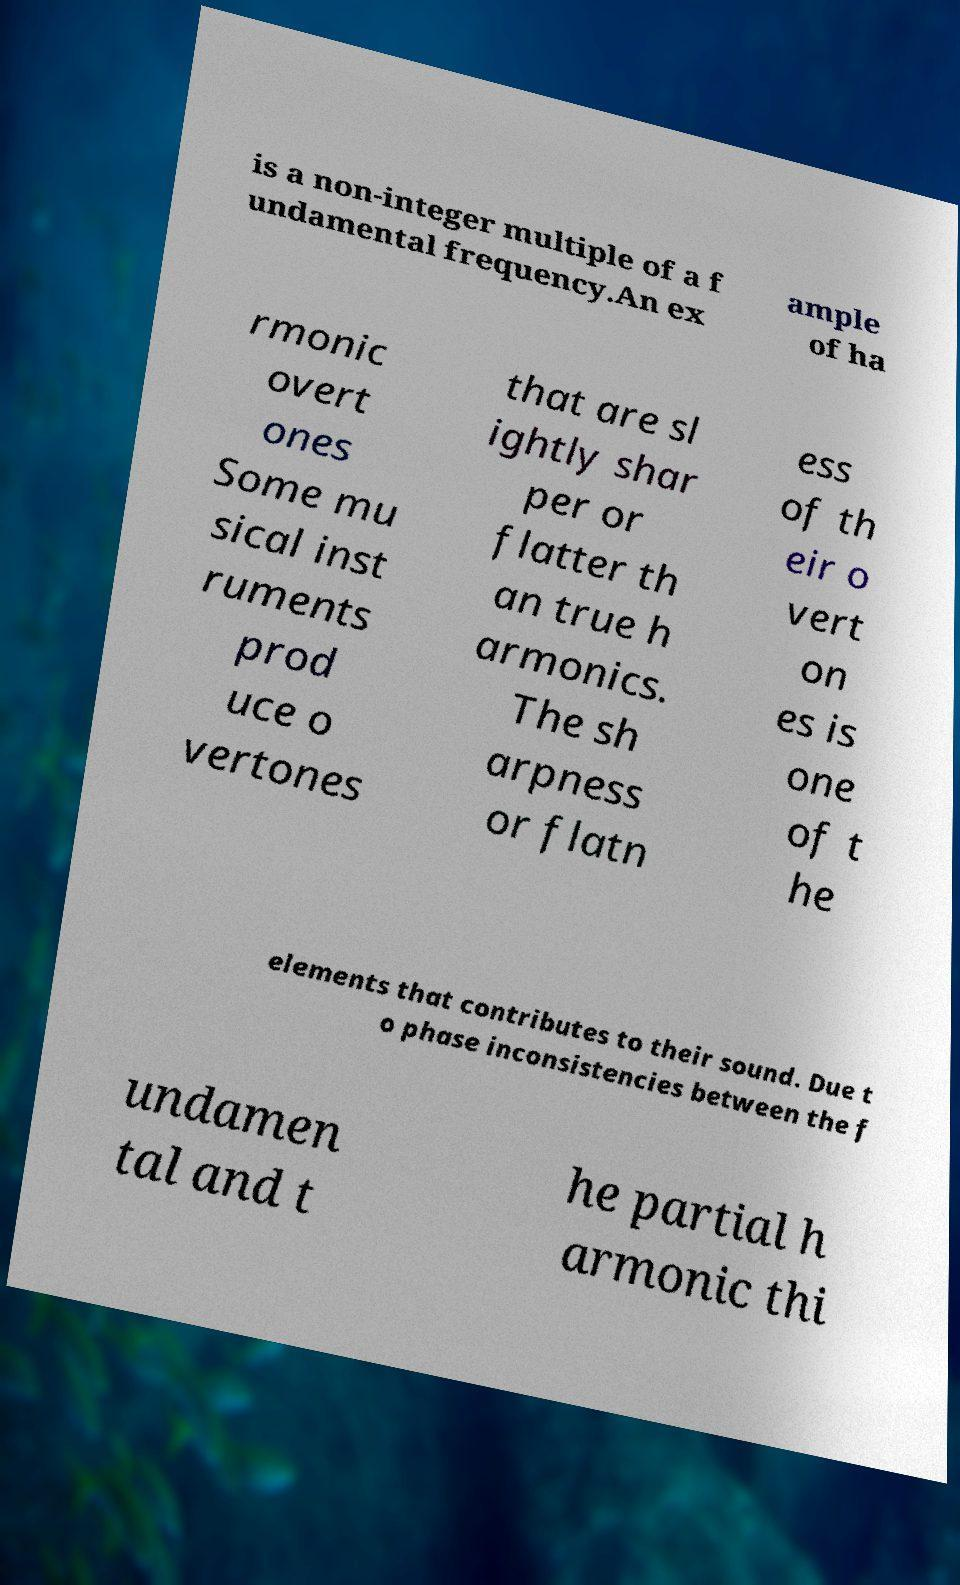Can you accurately transcribe the text from the provided image for me? is a non-integer multiple of a f undamental frequency.An ex ample of ha rmonic overt ones Some mu sical inst ruments prod uce o vertones that are sl ightly shar per or flatter th an true h armonics. The sh arpness or flatn ess of th eir o vert on es is one of t he elements that contributes to their sound. Due t o phase inconsistencies between the f undamen tal and t he partial h armonic thi 